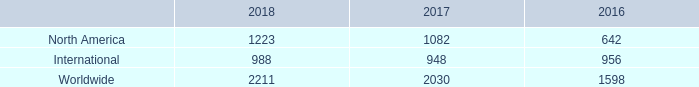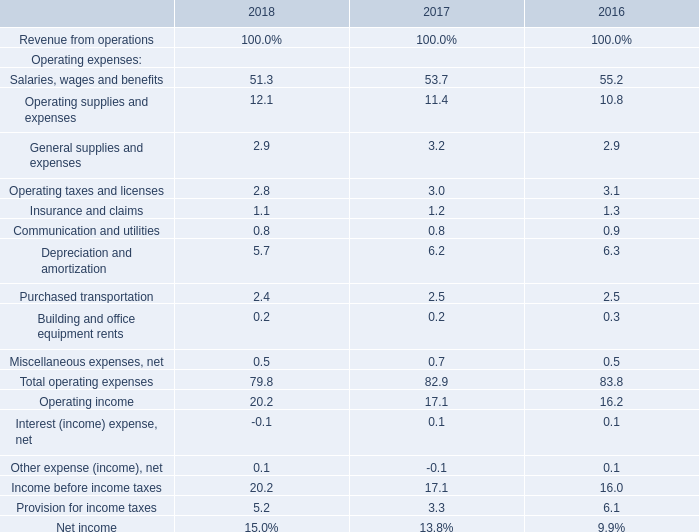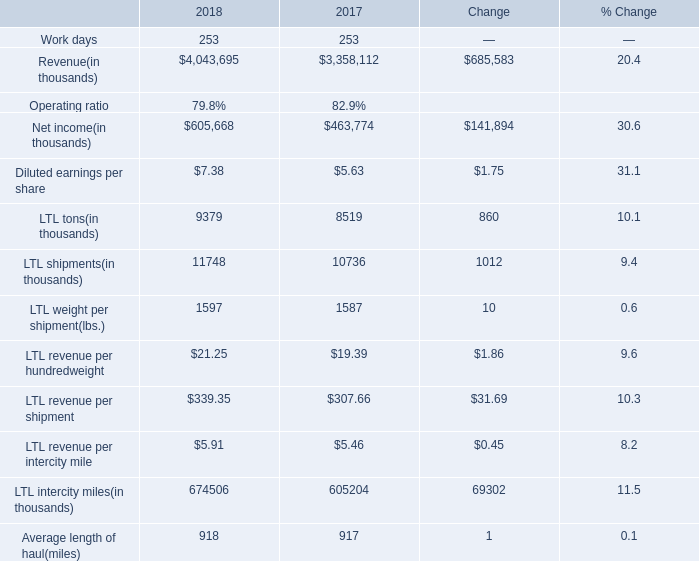What's the growth rate of Insurance and claims in 2017? 
Computations: ((1.2 - 1.3) / 1.3)
Answer: -0.07692. 